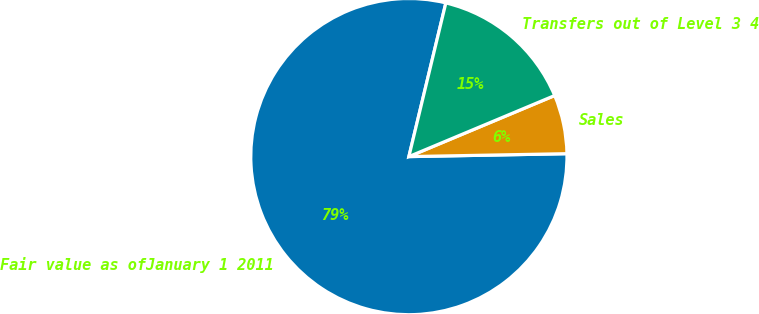Convert chart. <chart><loc_0><loc_0><loc_500><loc_500><pie_chart><fcel>Fair value as ofJanuary 1 2011<fcel>Sales<fcel>Transfers out of Level 3 4<nl><fcel>79.06%<fcel>6.02%<fcel>14.93%<nl></chart> 